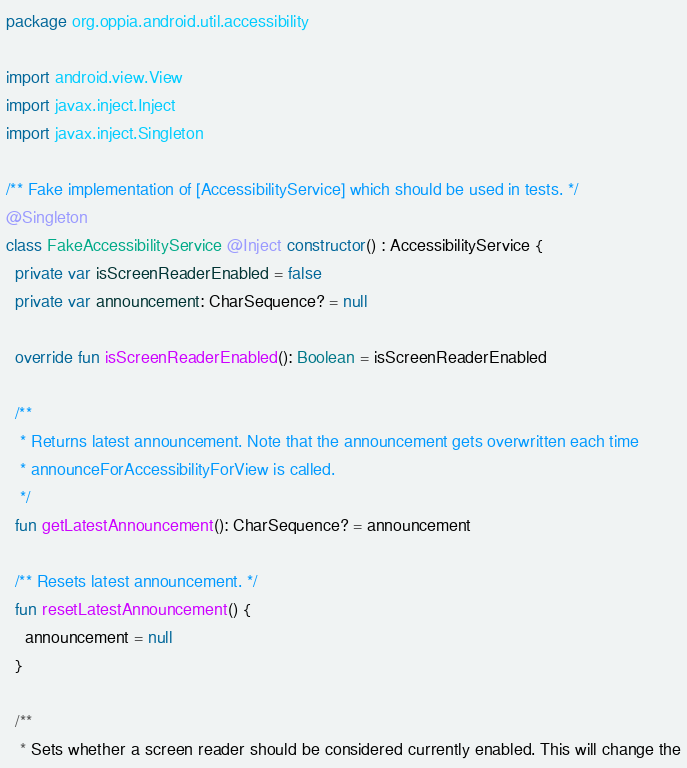Convert code to text. <code><loc_0><loc_0><loc_500><loc_500><_Kotlin_>package org.oppia.android.util.accessibility

import android.view.View
import javax.inject.Inject
import javax.inject.Singleton

/** Fake implementation of [AccessibilityService] which should be used in tests. */
@Singleton
class FakeAccessibilityService @Inject constructor() : AccessibilityService {
  private var isScreenReaderEnabled = false
  private var announcement: CharSequence? = null

  override fun isScreenReaderEnabled(): Boolean = isScreenReaderEnabled

  /**
   * Returns latest announcement. Note that the announcement gets overwritten each time
   * announceForAccessibilityForView is called.
   */
  fun getLatestAnnouncement(): CharSequence? = announcement

  /** Resets latest announcement. */
  fun resetLatestAnnouncement() {
    announcement = null
  }

  /**
   * Sets whether a screen reader should be considered currently enabled. This will change the</code> 